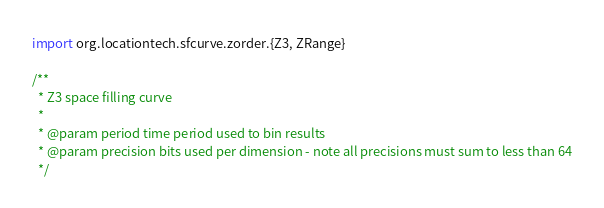<code> <loc_0><loc_0><loc_500><loc_500><_Scala_>import org.locationtech.sfcurve.zorder.{Z3, ZRange}

/**
  * Z3 space filling curve
  *
  * @param period time period used to bin results
  * @param precision bits used per dimension - note all precisions must sum to less than 64
  */</code> 